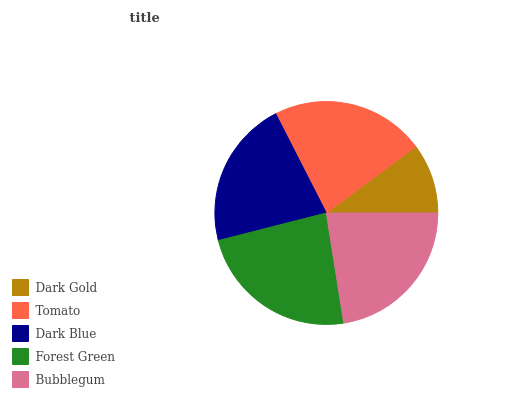Is Dark Gold the minimum?
Answer yes or no. Yes. Is Forest Green the maximum?
Answer yes or no. Yes. Is Tomato the minimum?
Answer yes or no. No. Is Tomato the maximum?
Answer yes or no. No. Is Tomato greater than Dark Gold?
Answer yes or no. Yes. Is Dark Gold less than Tomato?
Answer yes or no. Yes. Is Dark Gold greater than Tomato?
Answer yes or no. No. Is Tomato less than Dark Gold?
Answer yes or no. No. Is Tomato the high median?
Answer yes or no. Yes. Is Tomato the low median?
Answer yes or no. Yes. Is Bubblegum the high median?
Answer yes or no. No. Is Dark Blue the low median?
Answer yes or no. No. 